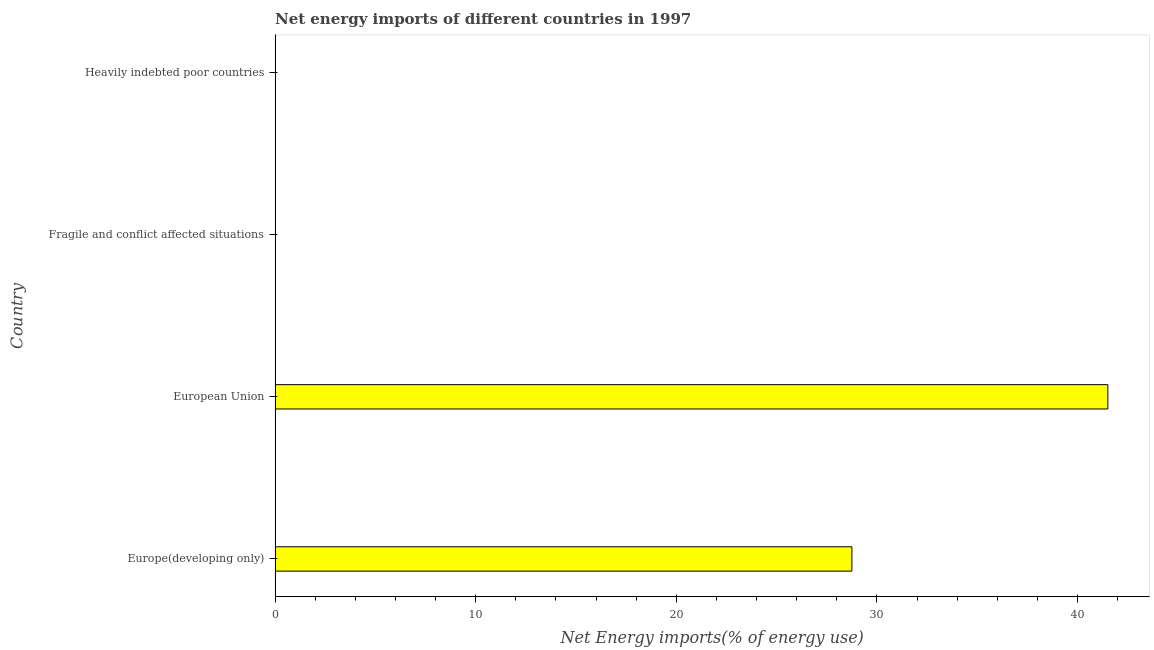What is the title of the graph?
Ensure brevity in your answer.  Net energy imports of different countries in 1997. What is the label or title of the X-axis?
Offer a terse response. Net Energy imports(% of energy use). What is the label or title of the Y-axis?
Your answer should be very brief. Country. What is the energy imports in European Union?
Provide a succinct answer. 41.51. Across all countries, what is the maximum energy imports?
Make the answer very short. 41.51. Across all countries, what is the minimum energy imports?
Keep it short and to the point. 0. In which country was the energy imports maximum?
Offer a very short reply. European Union. What is the sum of the energy imports?
Your response must be concise. 70.26. What is the difference between the energy imports in Europe(developing only) and European Union?
Your answer should be compact. -12.76. What is the average energy imports per country?
Provide a succinct answer. 17.57. What is the median energy imports?
Your answer should be very brief. 14.38. In how many countries, is the energy imports greater than 26 %?
Give a very brief answer. 2. Is the difference between the energy imports in Europe(developing only) and European Union greater than the difference between any two countries?
Give a very brief answer. No. What is the difference between the highest and the lowest energy imports?
Provide a succinct answer. 41.51. In how many countries, is the energy imports greater than the average energy imports taken over all countries?
Make the answer very short. 2. How many bars are there?
Your answer should be very brief. 2. What is the difference between two consecutive major ticks on the X-axis?
Your response must be concise. 10. Are the values on the major ticks of X-axis written in scientific E-notation?
Ensure brevity in your answer.  No. What is the Net Energy imports(% of energy use) in Europe(developing only)?
Your answer should be very brief. 28.75. What is the Net Energy imports(% of energy use) in European Union?
Offer a terse response. 41.51. What is the Net Energy imports(% of energy use) in Fragile and conflict affected situations?
Offer a terse response. 0. What is the Net Energy imports(% of energy use) in Heavily indebted poor countries?
Your answer should be compact. 0. What is the difference between the Net Energy imports(% of energy use) in Europe(developing only) and European Union?
Offer a terse response. -12.76. What is the ratio of the Net Energy imports(% of energy use) in Europe(developing only) to that in European Union?
Offer a terse response. 0.69. 